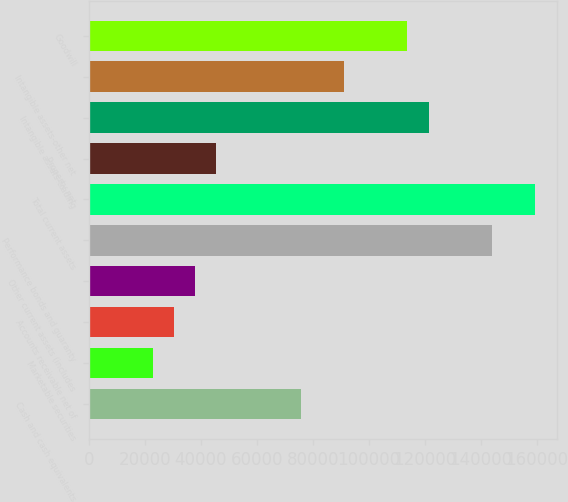Convert chart to OTSL. <chart><loc_0><loc_0><loc_500><loc_500><bar_chart><fcel>Cash and cash equivalents<fcel>Marketable securities<fcel>Accounts receivable net of<fcel>Other current assets (includes<fcel>Performance bonds and guaranty<fcel>Total current assets<fcel>Property net<fcel>Intangible assets-trading<fcel>Intangible assets-other net<fcel>Goodwill<nl><fcel>75791.2<fcel>22739.7<fcel>30318.5<fcel>37897.3<fcel>144000<fcel>159158<fcel>45476.1<fcel>121264<fcel>90948.8<fcel>113685<nl></chart> 